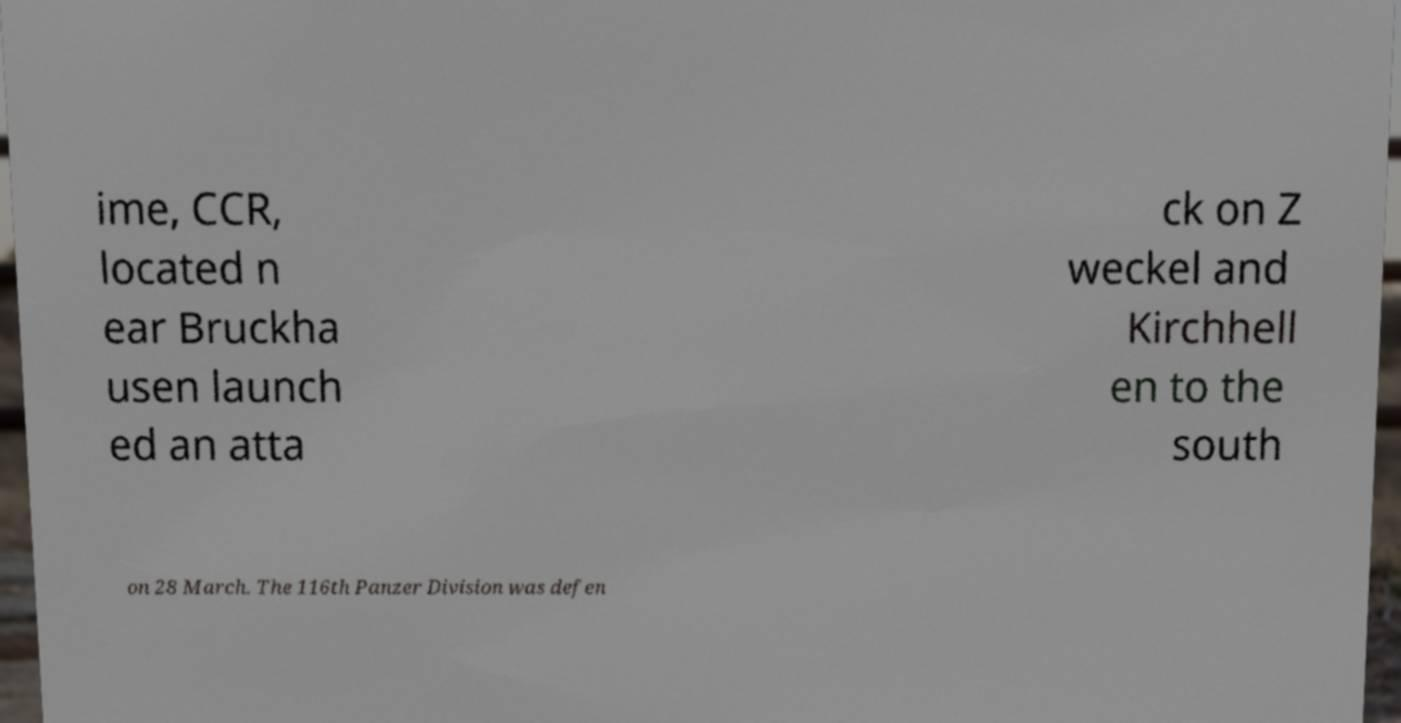Can you accurately transcribe the text from the provided image for me? ime, CCR, located n ear Bruckha usen launch ed an atta ck on Z weckel and Kirchhell en to the south on 28 March. The 116th Panzer Division was defen 